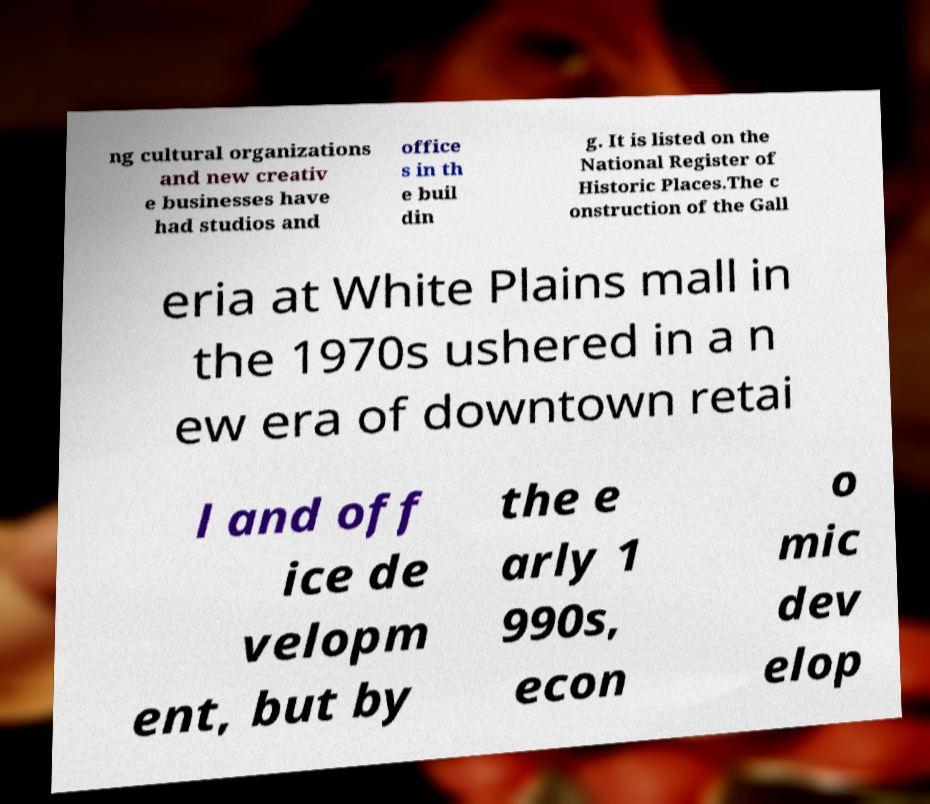I need the written content from this picture converted into text. Can you do that? ng cultural organizations and new creativ e businesses have had studios and office s in th e buil din g. It is listed on the National Register of Historic Places.The c onstruction of the Gall eria at White Plains mall in the 1970s ushered in a n ew era of downtown retai l and off ice de velopm ent, but by the e arly 1 990s, econ o mic dev elop 